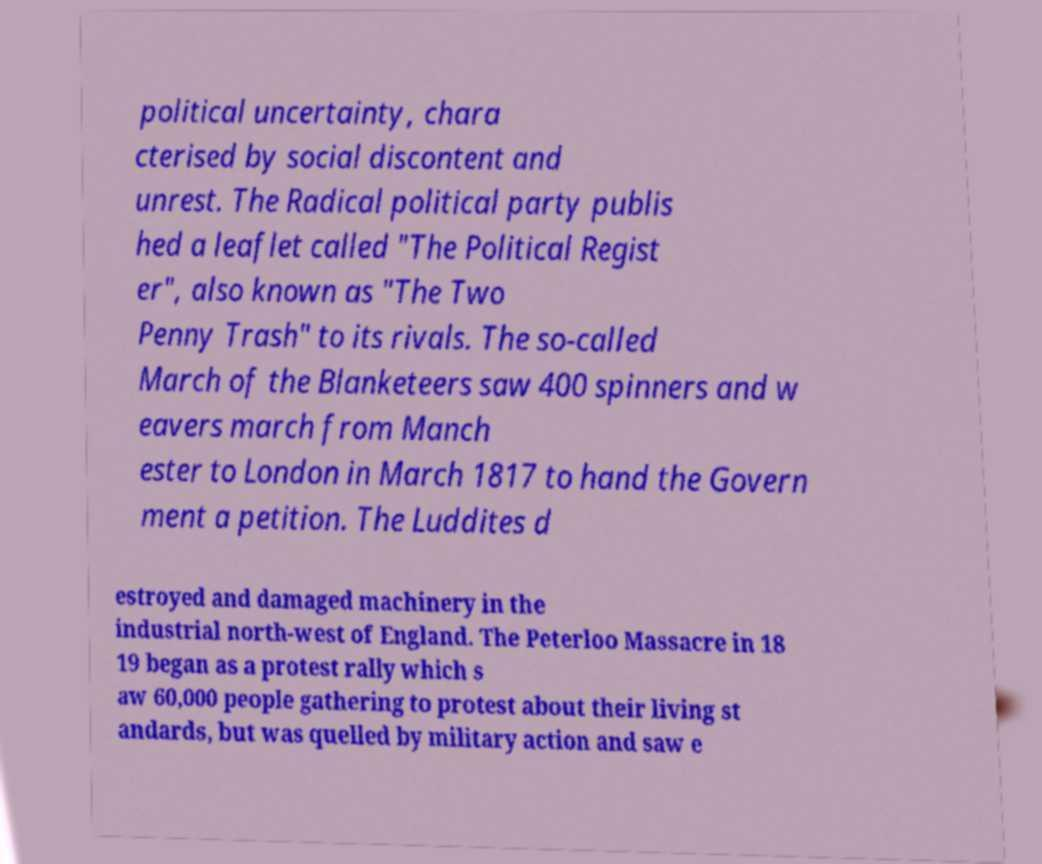Could you extract and type out the text from this image? political uncertainty, chara cterised by social discontent and unrest. The Radical political party publis hed a leaflet called "The Political Regist er", also known as "The Two Penny Trash" to its rivals. The so-called March of the Blanketeers saw 400 spinners and w eavers march from Manch ester to London in March 1817 to hand the Govern ment a petition. The Luddites d estroyed and damaged machinery in the industrial north-west of England. The Peterloo Massacre in 18 19 began as a protest rally which s aw 60,000 people gathering to protest about their living st andards, but was quelled by military action and saw e 